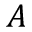<formula> <loc_0><loc_0><loc_500><loc_500>A</formula> 